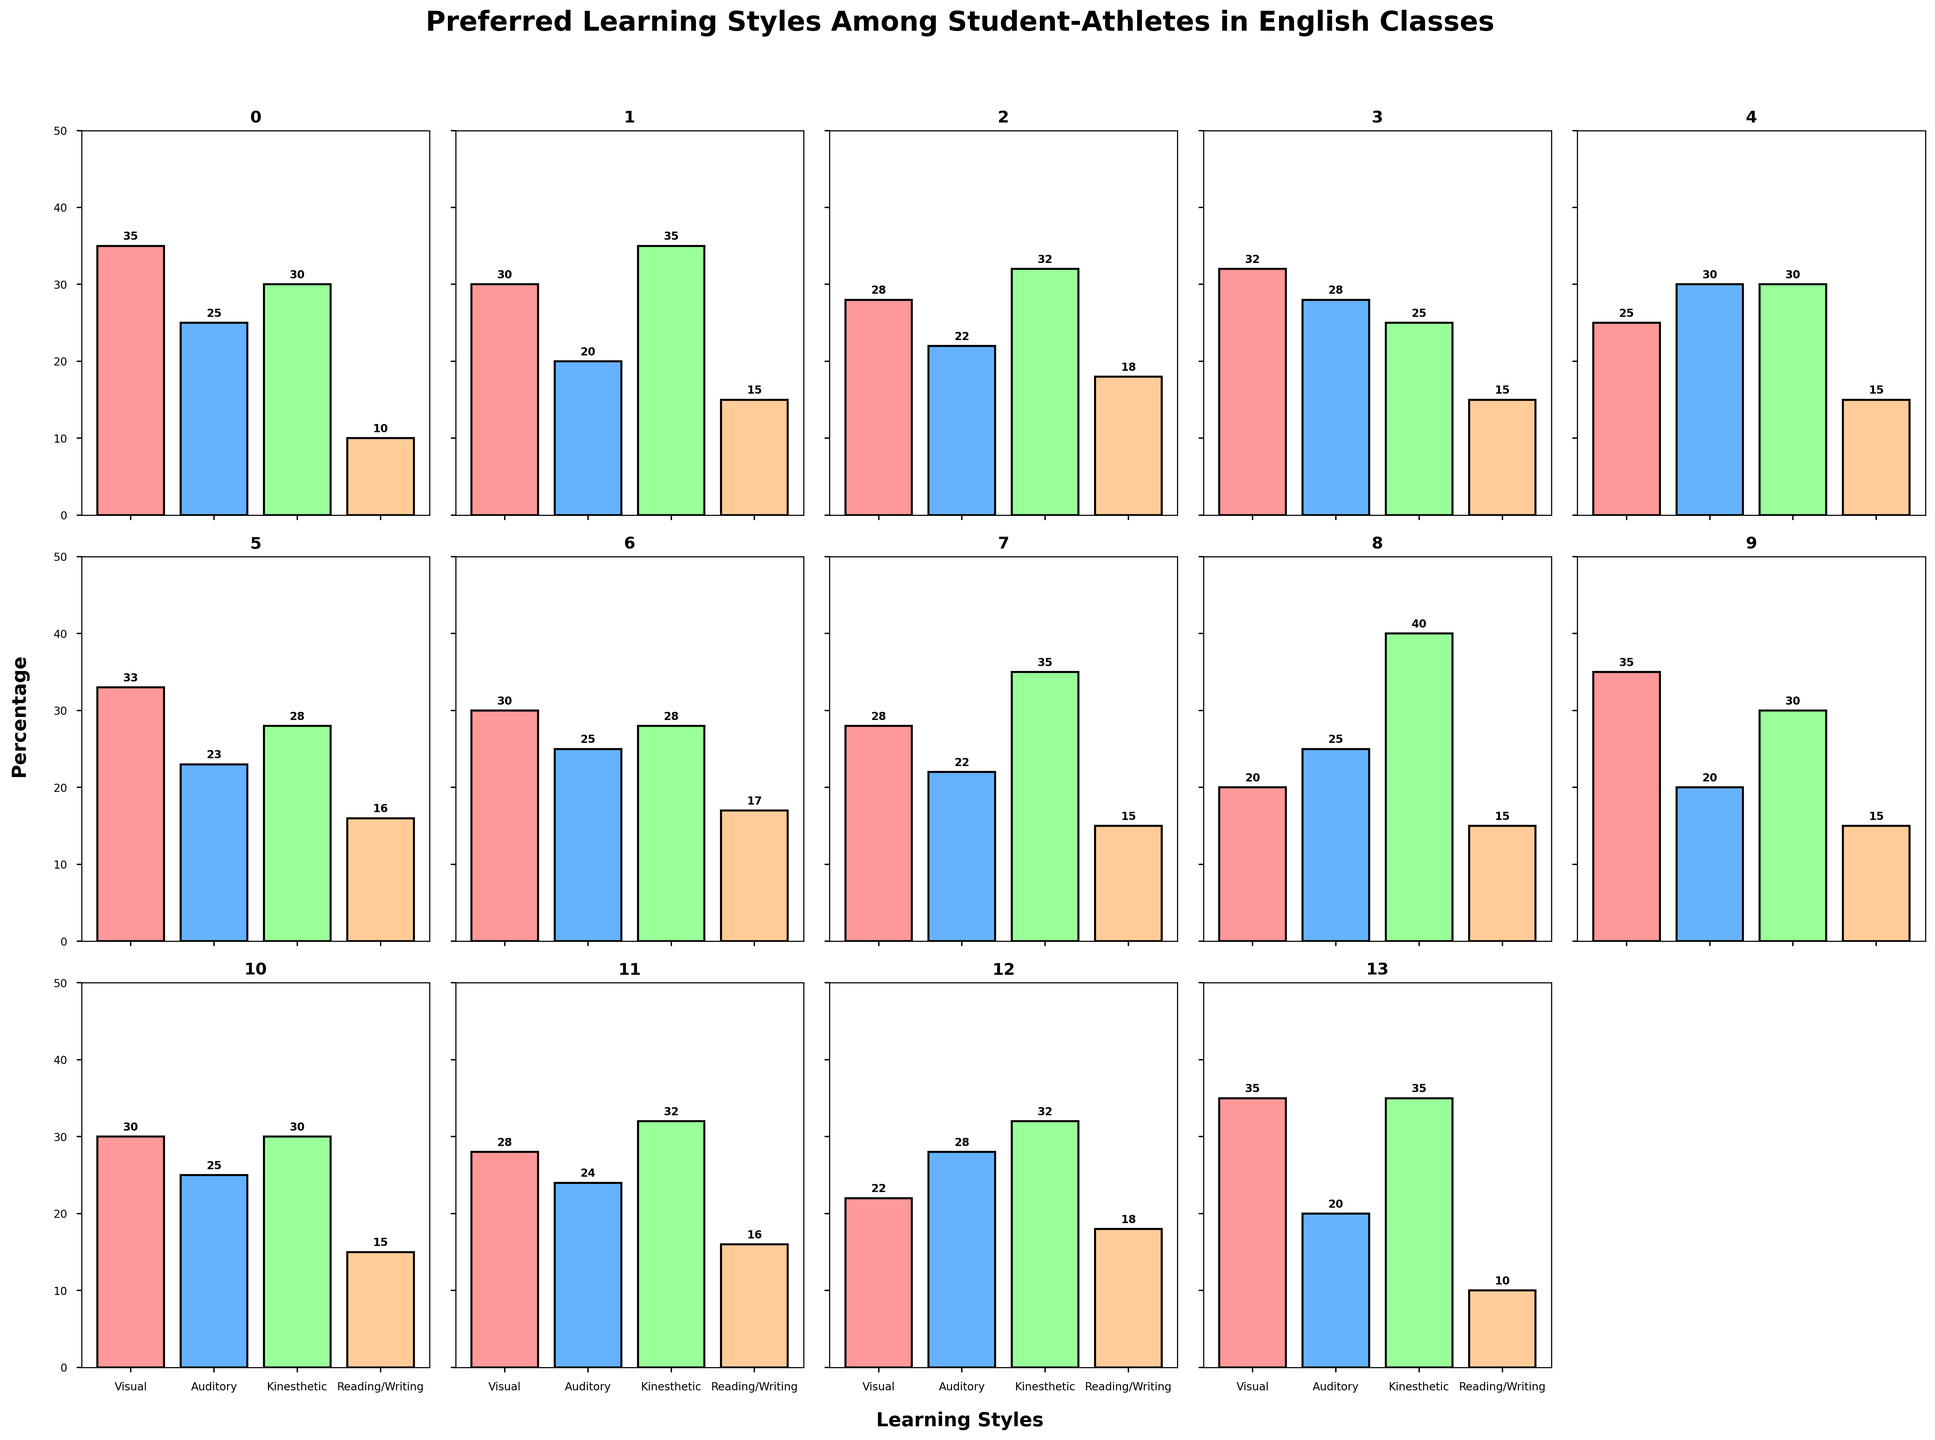Which sport has the highest percentage of kinesthetic learners? Look at the bar heights for kinesthetic learning style across all sports. The tallest bar represents the highest percentage. Wrestlers have the highest percentage with a value of 40%.
Answer: Wrestlers Which sport has the lowest percentage of reading/writing preference? Look at the bar heights for the reading/writing learning style across all sports. The shortest bar represents the lowest percentage. Both Football Players and Gymnasts have the lowest percentage with a value of 10%.
Answer: Football Players and Gymnasts What is the average percentage of visual learners among all the sports? Sum the percentages of visual learners for each sport and divide by the number of sports (14). Calculation: (35+30+28+32+25+33+30+28+20+35+30+28+22+35)/14 = 29.21
Answer: 29.21 Compare the preference for auditory learning style between Swimmers and Track Athletes. Which group has a higher percentage? Check the respective bar heights for auditory learning style for Swimmers and Track Athletes. Swimmers have 28% while Track Athletes have 30%. Track Athletes have a higher percentage.
Answer: Track Athletes What is the total percentage of kinesthetic learners among Baseball/Softball Players and Basketball Players combined? Add the percentages of kinesthetic learners from Baseball/Softball Players (35%) and Basketball Players (35%). Calculation: 35 + 35 = 70
Answer: 70 Which group prefers auditory learning over kinesthetic learning? Identify sports where the bar for auditory learning is taller than the bar for kinesthetic. Track Athletes have this characteristic with 30% auditory and 30% kinesthetic. Although both are equal, none exceed each other. No other sports fit this condition.
Answer: None Compare the visual learning preference of Gymnasts with Visual learning preference of Football Players. Which is higher? Look at the visual learning bars for Gymnasts (35%) and Football Players (35%). Both are equal at 35%.
Answer: Equal What is the percentage difference in auditory learners between Soccer Players and Volleyball Players? Subtract the percentage of auditory learning in Volleyball Players (23%) from Soccer Players (22%). Calculation: 22 - 23 = -1
Answer: -1 Which group has the most balanced preference across all learning styles? Determine this by checking for the minimal variation between the highest and lowest percentages within each sport. Soccer Players have values of 28, 22, 32, and 18, with a range of 14. This is minimal compared to others.
Answer: Soccer Players What learning style is preferred by Golfers the least? Check the shortest bar for Golfers to see which represents the lowest percentage. Auditory learning has the lowest percentage at 20%.
Answer: Auditory 